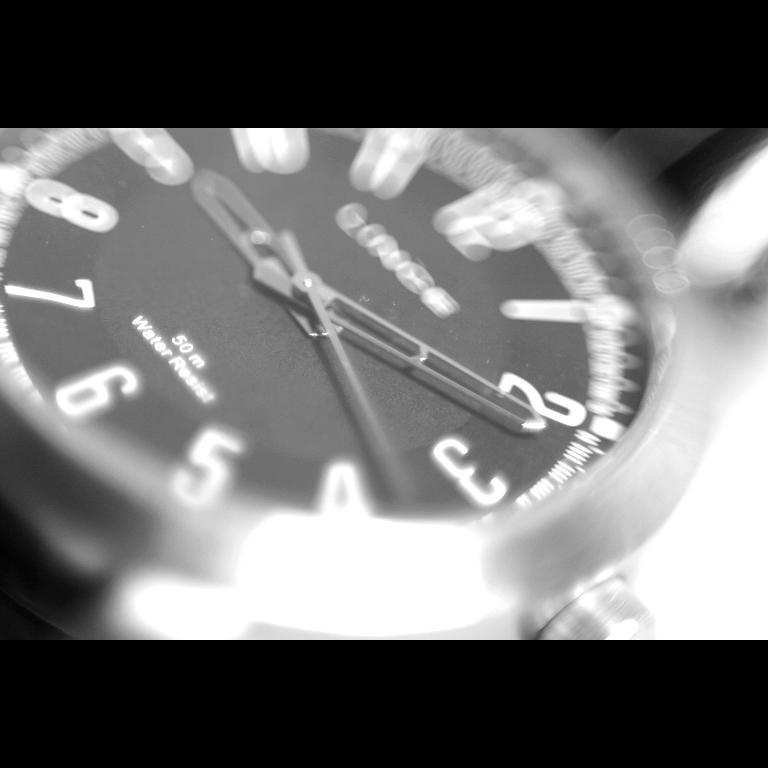<image>
Present a compact description of the photo's key features. A watch face advertises that it is 50 m water resistant. 